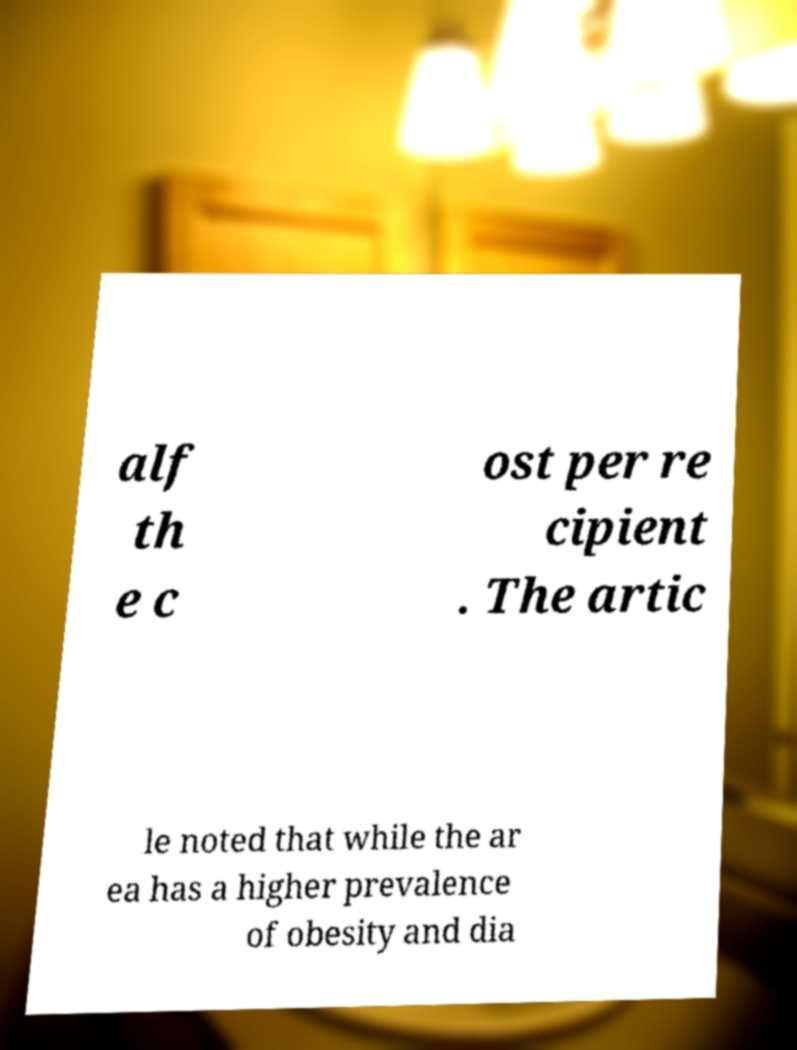I need the written content from this picture converted into text. Can you do that? alf th e c ost per re cipient . The artic le noted that while the ar ea has a higher prevalence of obesity and dia 